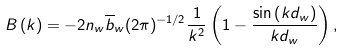<formula> <loc_0><loc_0><loc_500><loc_500>B \left ( k \right ) = - 2 n _ { w } \overline { b } _ { w } ( 2 \pi ) ^ { - 1 / 2 } \frac { 1 } { k ^ { 2 } } \left ( 1 - \frac { \sin \left ( k d _ { w } \right ) } { k d _ { w } } \right ) ,</formula> 